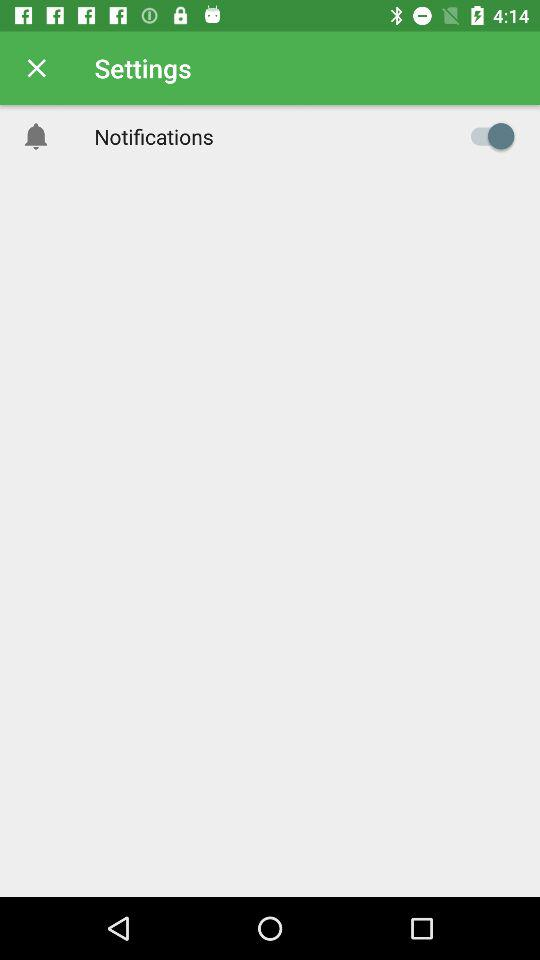What is the user's name?
When the provided information is insufficient, respond with <no answer>. <no answer> 